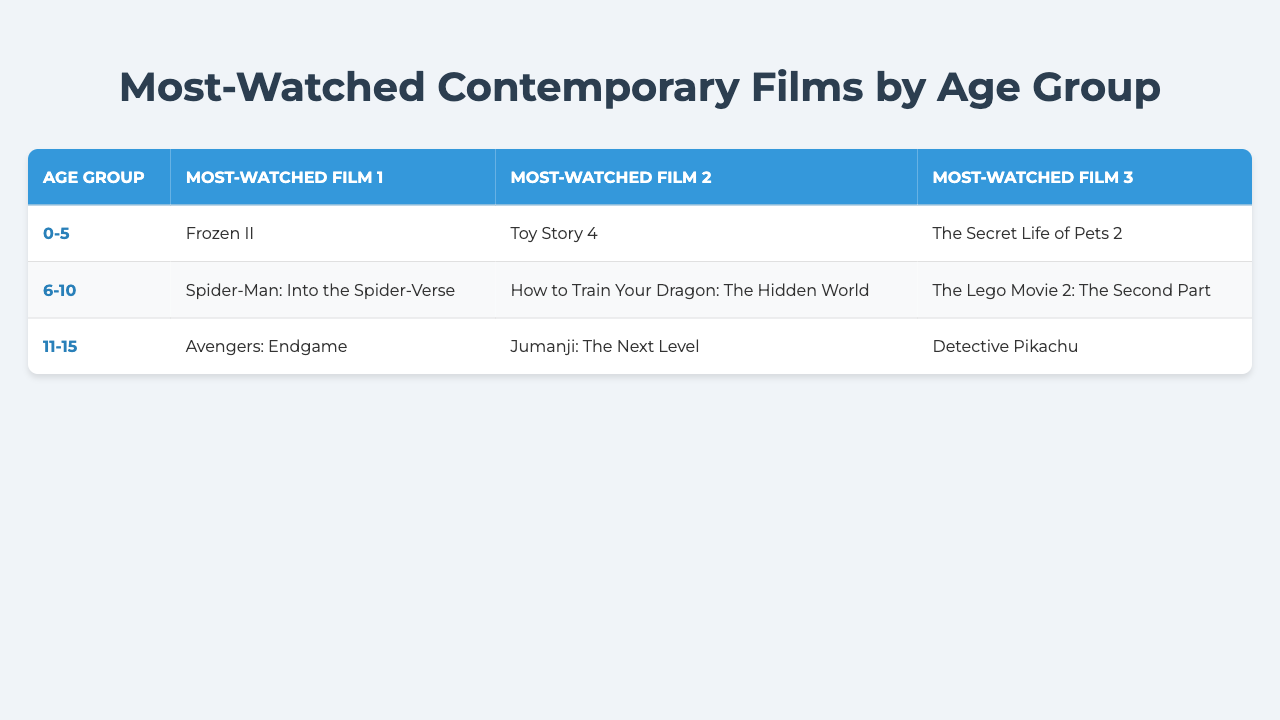What is the most-watched film for the age group 0-5? The table shows that the most-watched film for the age group 0-5 is "Frozen II."
Answer: Frozen II How many films are listed for each age group? Each age group in the table lists three films as the most-watched.
Answer: Three films Which film is most watched by the age group 11-15? According to the table, the most-watched film for the age group 11-15 is "Avengers: Endgame."
Answer: Avengers: Endgame Is "Toy Story 4" listed as a popular film for the age group 6-10? The table indicates that "Toy Story 4" is listed under the age group 0-5, not 6-10.
Answer: No Which age group has "How to Train Your Dragon: The Hidden World" as a top film? The film "How to Train Your Dragon: The Hidden World" appears for the age group 6-10, as per the table.
Answer: 6-10 What is the sum of the ages for the three age groups represented? The age groups are 0-5, 6-10, and 11-15. The median ages are roughly 3, 8, and 13. Adding these gives 3 + 8 + 13 = 24.
Answer: 24 Which group has the most superhero-themed films? Looking at the table, the 11-15 age group has one superhero-themed film "Avengers: Endgame" and the 6-10 age group has one with "Spider-Man: Into the Spider-Verse," giving the 11-15 group the lead with one more.
Answer: 11-15 Are there any films common between the age groups 0-5 and 11-15? Checking the films listed for both age groups shows that there are no films that are common between them.
Answer: No What is the average viewed film rating in the 6-10 age group? Although specific ratings aren't provided in the table, we could infer that most kids' films have high ratings, but we can't calculate an average without that data.
Answer: Cannot determine Which film appears twice in the most-watched lists? Each film listed in the table occurs only once; therefore, there are no films that appear multiple times across the age group lists.
Answer: None 